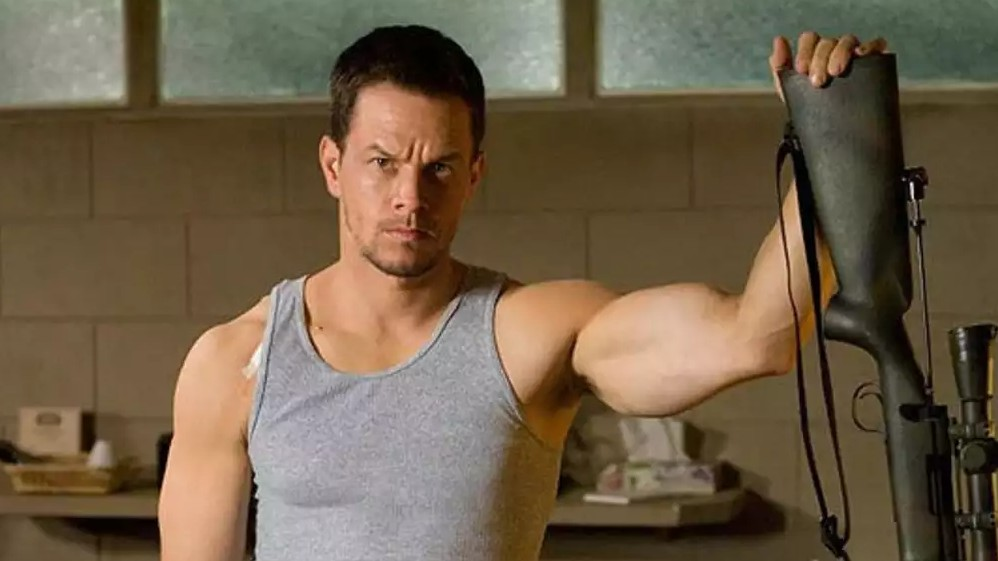Explain the visual content of the image in great detail. In the image, a muscular man is standing in what appears to be a well-lit indoor room with a window casting natural light onto his figure. He wears a snug gray tank top, showcasing his toned arms, and his facial expression is earnest, hinting at a serious or tense scenario. He comfortably holds a black rifle with a strap, suggesting familiarity with the gear. His gaze is directed slightly off-camera, adding a candid quality to the depiction. The setting behind him is plain, possibly a garage or workshop area, hinting at a utilitarian purpose of the space. 